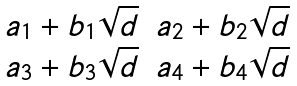<formula> <loc_0><loc_0><loc_500><loc_500>\begin{matrix} a _ { 1 } + b _ { 1 } \sqrt { d } & a _ { 2 } + b _ { 2 } \sqrt { d } \\ a _ { 3 } + b _ { 3 } \sqrt { d } & a _ { 4 } + b _ { 4 } \sqrt { d } \end{matrix}</formula> 